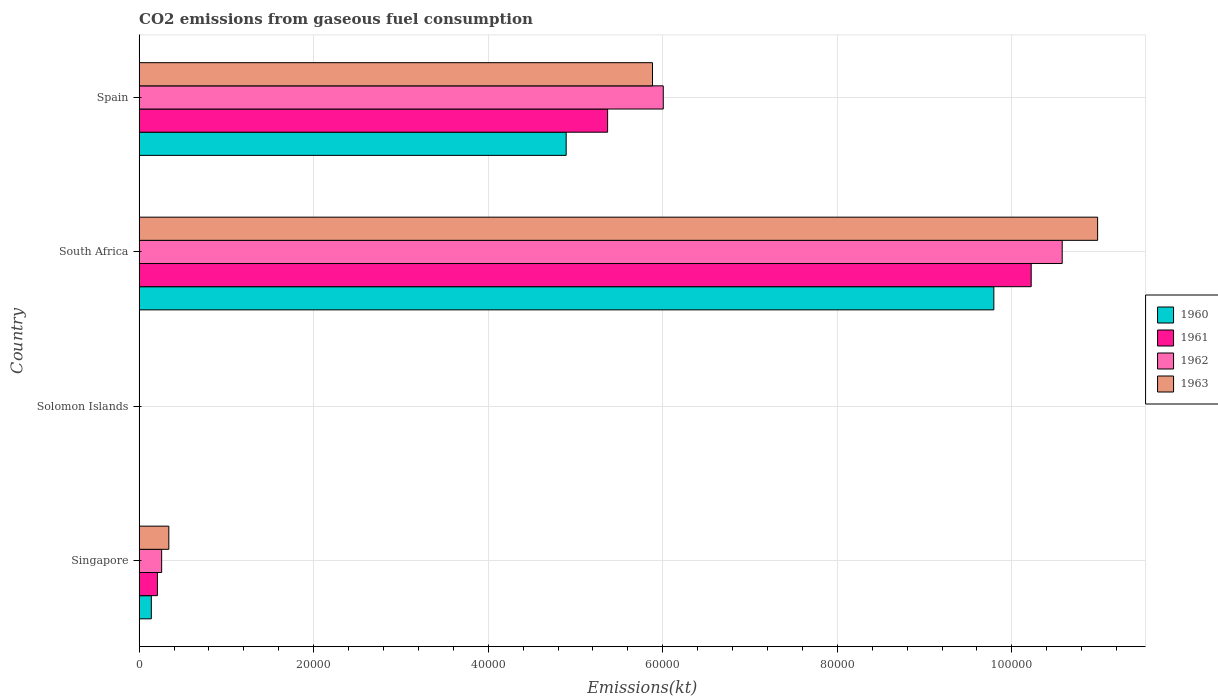How many different coloured bars are there?
Offer a terse response. 4. How many bars are there on the 2nd tick from the bottom?
Provide a succinct answer. 4. What is the label of the 2nd group of bars from the top?
Provide a short and direct response. South Africa. What is the amount of CO2 emitted in 1960 in Solomon Islands?
Ensure brevity in your answer.  11. Across all countries, what is the maximum amount of CO2 emitted in 1960?
Provide a short and direct response. 9.79e+04. Across all countries, what is the minimum amount of CO2 emitted in 1963?
Your answer should be compact. 14.67. In which country was the amount of CO2 emitted in 1961 maximum?
Your answer should be very brief. South Africa. In which country was the amount of CO2 emitted in 1963 minimum?
Offer a very short reply. Solomon Islands. What is the total amount of CO2 emitted in 1961 in the graph?
Provide a succinct answer. 1.58e+05. What is the difference between the amount of CO2 emitted in 1963 in Singapore and that in Solomon Islands?
Your answer should be compact. 3384.64. What is the difference between the amount of CO2 emitted in 1962 in Solomon Islands and the amount of CO2 emitted in 1963 in Singapore?
Make the answer very short. -3384.64. What is the average amount of CO2 emitted in 1961 per country?
Offer a terse response. 3.95e+04. What is the difference between the amount of CO2 emitted in 1961 and amount of CO2 emitted in 1960 in South Africa?
Provide a short and direct response. 4279.39. In how many countries, is the amount of CO2 emitted in 1960 greater than 64000 kt?
Provide a succinct answer. 1. What is the ratio of the amount of CO2 emitted in 1962 in Solomon Islands to that in South Africa?
Ensure brevity in your answer.  0. Is the amount of CO2 emitted in 1961 in South Africa less than that in Spain?
Your response must be concise. No. Is the difference between the amount of CO2 emitted in 1961 in Solomon Islands and South Africa greater than the difference between the amount of CO2 emitted in 1960 in Solomon Islands and South Africa?
Offer a very short reply. No. What is the difference between the highest and the second highest amount of CO2 emitted in 1963?
Your answer should be very brief. 5.10e+04. What is the difference between the highest and the lowest amount of CO2 emitted in 1960?
Give a very brief answer. 9.79e+04. Are all the bars in the graph horizontal?
Your response must be concise. Yes. How many countries are there in the graph?
Provide a short and direct response. 4. What is the difference between two consecutive major ticks on the X-axis?
Keep it short and to the point. 2.00e+04. Are the values on the major ticks of X-axis written in scientific E-notation?
Offer a very short reply. No. Does the graph contain any zero values?
Your answer should be compact. No. Does the graph contain grids?
Offer a terse response. Yes. How many legend labels are there?
Provide a short and direct response. 4. What is the title of the graph?
Give a very brief answer. CO2 emissions from gaseous fuel consumption. What is the label or title of the X-axis?
Your answer should be very brief. Emissions(kt). What is the label or title of the Y-axis?
Provide a succinct answer. Country. What is the Emissions(kt) in 1960 in Singapore?
Keep it short and to the point. 1393.46. What is the Emissions(kt) of 1961 in Singapore?
Your answer should be very brief. 2093.86. What is the Emissions(kt) of 1962 in Singapore?
Offer a terse response. 2577.9. What is the Emissions(kt) in 1963 in Singapore?
Your answer should be compact. 3399.31. What is the Emissions(kt) in 1960 in Solomon Islands?
Ensure brevity in your answer.  11. What is the Emissions(kt) in 1961 in Solomon Islands?
Make the answer very short. 14.67. What is the Emissions(kt) in 1962 in Solomon Islands?
Your answer should be compact. 14.67. What is the Emissions(kt) of 1963 in Solomon Islands?
Ensure brevity in your answer.  14.67. What is the Emissions(kt) in 1960 in South Africa?
Your response must be concise. 9.79e+04. What is the Emissions(kt) in 1961 in South Africa?
Provide a short and direct response. 1.02e+05. What is the Emissions(kt) in 1962 in South Africa?
Your answer should be very brief. 1.06e+05. What is the Emissions(kt) in 1963 in South Africa?
Offer a very short reply. 1.10e+05. What is the Emissions(kt) in 1960 in Spain?
Keep it short and to the point. 4.89e+04. What is the Emissions(kt) of 1961 in Spain?
Ensure brevity in your answer.  5.37e+04. What is the Emissions(kt) of 1962 in Spain?
Your response must be concise. 6.01e+04. What is the Emissions(kt) in 1963 in Spain?
Make the answer very short. 5.88e+04. Across all countries, what is the maximum Emissions(kt) of 1960?
Provide a short and direct response. 9.79e+04. Across all countries, what is the maximum Emissions(kt) of 1961?
Offer a very short reply. 1.02e+05. Across all countries, what is the maximum Emissions(kt) of 1962?
Keep it short and to the point. 1.06e+05. Across all countries, what is the maximum Emissions(kt) in 1963?
Your answer should be very brief. 1.10e+05. Across all countries, what is the minimum Emissions(kt) of 1960?
Offer a very short reply. 11. Across all countries, what is the minimum Emissions(kt) of 1961?
Your answer should be compact. 14.67. Across all countries, what is the minimum Emissions(kt) of 1962?
Keep it short and to the point. 14.67. Across all countries, what is the minimum Emissions(kt) in 1963?
Provide a short and direct response. 14.67. What is the total Emissions(kt) of 1960 in the graph?
Offer a terse response. 1.48e+05. What is the total Emissions(kt) of 1961 in the graph?
Ensure brevity in your answer.  1.58e+05. What is the total Emissions(kt) in 1962 in the graph?
Offer a very short reply. 1.68e+05. What is the total Emissions(kt) of 1963 in the graph?
Your response must be concise. 1.72e+05. What is the difference between the Emissions(kt) in 1960 in Singapore and that in Solomon Islands?
Offer a terse response. 1382.46. What is the difference between the Emissions(kt) of 1961 in Singapore and that in Solomon Islands?
Provide a succinct answer. 2079.19. What is the difference between the Emissions(kt) of 1962 in Singapore and that in Solomon Islands?
Offer a terse response. 2563.23. What is the difference between the Emissions(kt) of 1963 in Singapore and that in Solomon Islands?
Your answer should be very brief. 3384.64. What is the difference between the Emissions(kt) in 1960 in Singapore and that in South Africa?
Your answer should be compact. -9.65e+04. What is the difference between the Emissions(kt) in 1961 in Singapore and that in South Africa?
Make the answer very short. -1.00e+05. What is the difference between the Emissions(kt) of 1962 in Singapore and that in South Africa?
Give a very brief answer. -1.03e+05. What is the difference between the Emissions(kt) of 1963 in Singapore and that in South Africa?
Offer a terse response. -1.06e+05. What is the difference between the Emissions(kt) in 1960 in Singapore and that in Spain?
Keep it short and to the point. -4.75e+04. What is the difference between the Emissions(kt) of 1961 in Singapore and that in Spain?
Provide a short and direct response. -5.16e+04. What is the difference between the Emissions(kt) of 1962 in Singapore and that in Spain?
Ensure brevity in your answer.  -5.75e+04. What is the difference between the Emissions(kt) in 1963 in Singapore and that in Spain?
Provide a short and direct response. -5.54e+04. What is the difference between the Emissions(kt) in 1960 in Solomon Islands and that in South Africa?
Keep it short and to the point. -9.79e+04. What is the difference between the Emissions(kt) of 1961 in Solomon Islands and that in South Africa?
Give a very brief answer. -1.02e+05. What is the difference between the Emissions(kt) of 1962 in Solomon Islands and that in South Africa?
Provide a short and direct response. -1.06e+05. What is the difference between the Emissions(kt) of 1963 in Solomon Islands and that in South Africa?
Provide a short and direct response. -1.10e+05. What is the difference between the Emissions(kt) of 1960 in Solomon Islands and that in Spain?
Your response must be concise. -4.89e+04. What is the difference between the Emissions(kt) of 1961 in Solomon Islands and that in Spain?
Provide a succinct answer. -5.37e+04. What is the difference between the Emissions(kt) of 1962 in Solomon Islands and that in Spain?
Keep it short and to the point. -6.00e+04. What is the difference between the Emissions(kt) in 1963 in Solomon Islands and that in Spain?
Provide a short and direct response. -5.88e+04. What is the difference between the Emissions(kt) in 1960 in South Africa and that in Spain?
Your answer should be compact. 4.90e+04. What is the difference between the Emissions(kt) in 1961 in South Africa and that in Spain?
Make the answer very short. 4.85e+04. What is the difference between the Emissions(kt) in 1962 in South Africa and that in Spain?
Your response must be concise. 4.57e+04. What is the difference between the Emissions(kt) of 1963 in South Africa and that in Spain?
Offer a terse response. 5.10e+04. What is the difference between the Emissions(kt) in 1960 in Singapore and the Emissions(kt) in 1961 in Solomon Islands?
Offer a terse response. 1378.79. What is the difference between the Emissions(kt) of 1960 in Singapore and the Emissions(kt) of 1962 in Solomon Islands?
Keep it short and to the point. 1378.79. What is the difference between the Emissions(kt) of 1960 in Singapore and the Emissions(kt) of 1963 in Solomon Islands?
Offer a terse response. 1378.79. What is the difference between the Emissions(kt) of 1961 in Singapore and the Emissions(kt) of 1962 in Solomon Islands?
Your answer should be compact. 2079.19. What is the difference between the Emissions(kt) of 1961 in Singapore and the Emissions(kt) of 1963 in Solomon Islands?
Ensure brevity in your answer.  2079.19. What is the difference between the Emissions(kt) in 1962 in Singapore and the Emissions(kt) in 1963 in Solomon Islands?
Your response must be concise. 2563.23. What is the difference between the Emissions(kt) in 1960 in Singapore and the Emissions(kt) in 1961 in South Africa?
Provide a short and direct response. -1.01e+05. What is the difference between the Emissions(kt) of 1960 in Singapore and the Emissions(kt) of 1962 in South Africa?
Give a very brief answer. -1.04e+05. What is the difference between the Emissions(kt) in 1960 in Singapore and the Emissions(kt) in 1963 in South Africa?
Provide a succinct answer. -1.08e+05. What is the difference between the Emissions(kt) in 1961 in Singapore and the Emissions(kt) in 1962 in South Africa?
Give a very brief answer. -1.04e+05. What is the difference between the Emissions(kt) of 1961 in Singapore and the Emissions(kt) of 1963 in South Africa?
Provide a succinct answer. -1.08e+05. What is the difference between the Emissions(kt) in 1962 in Singapore and the Emissions(kt) in 1963 in South Africa?
Offer a terse response. -1.07e+05. What is the difference between the Emissions(kt) of 1960 in Singapore and the Emissions(kt) of 1961 in Spain?
Provide a succinct answer. -5.23e+04. What is the difference between the Emissions(kt) of 1960 in Singapore and the Emissions(kt) of 1962 in Spain?
Provide a short and direct response. -5.87e+04. What is the difference between the Emissions(kt) of 1960 in Singapore and the Emissions(kt) of 1963 in Spain?
Offer a terse response. -5.74e+04. What is the difference between the Emissions(kt) of 1961 in Singapore and the Emissions(kt) of 1962 in Spain?
Offer a very short reply. -5.80e+04. What is the difference between the Emissions(kt) in 1961 in Singapore and the Emissions(kt) in 1963 in Spain?
Make the answer very short. -5.67e+04. What is the difference between the Emissions(kt) in 1962 in Singapore and the Emissions(kt) in 1963 in Spain?
Your answer should be compact. -5.62e+04. What is the difference between the Emissions(kt) in 1960 in Solomon Islands and the Emissions(kt) in 1961 in South Africa?
Give a very brief answer. -1.02e+05. What is the difference between the Emissions(kt) of 1960 in Solomon Islands and the Emissions(kt) of 1962 in South Africa?
Offer a very short reply. -1.06e+05. What is the difference between the Emissions(kt) of 1960 in Solomon Islands and the Emissions(kt) of 1963 in South Africa?
Your answer should be very brief. -1.10e+05. What is the difference between the Emissions(kt) in 1961 in Solomon Islands and the Emissions(kt) in 1962 in South Africa?
Offer a very short reply. -1.06e+05. What is the difference between the Emissions(kt) of 1961 in Solomon Islands and the Emissions(kt) of 1963 in South Africa?
Your answer should be very brief. -1.10e+05. What is the difference between the Emissions(kt) of 1962 in Solomon Islands and the Emissions(kt) of 1963 in South Africa?
Your answer should be compact. -1.10e+05. What is the difference between the Emissions(kt) in 1960 in Solomon Islands and the Emissions(kt) in 1961 in Spain?
Offer a very short reply. -5.37e+04. What is the difference between the Emissions(kt) of 1960 in Solomon Islands and the Emissions(kt) of 1962 in Spain?
Offer a very short reply. -6.00e+04. What is the difference between the Emissions(kt) of 1960 in Solomon Islands and the Emissions(kt) of 1963 in Spain?
Offer a very short reply. -5.88e+04. What is the difference between the Emissions(kt) of 1961 in Solomon Islands and the Emissions(kt) of 1962 in Spain?
Offer a terse response. -6.00e+04. What is the difference between the Emissions(kt) of 1961 in Solomon Islands and the Emissions(kt) of 1963 in Spain?
Your answer should be very brief. -5.88e+04. What is the difference between the Emissions(kt) of 1962 in Solomon Islands and the Emissions(kt) of 1963 in Spain?
Your answer should be compact. -5.88e+04. What is the difference between the Emissions(kt) in 1960 in South Africa and the Emissions(kt) in 1961 in Spain?
Give a very brief answer. 4.43e+04. What is the difference between the Emissions(kt) of 1960 in South Africa and the Emissions(kt) of 1962 in Spain?
Keep it short and to the point. 3.79e+04. What is the difference between the Emissions(kt) in 1960 in South Africa and the Emissions(kt) in 1963 in Spain?
Provide a succinct answer. 3.91e+04. What is the difference between the Emissions(kt) of 1961 in South Africa and the Emissions(kt) of 1962 in Spain?
Make the answer very short. 4.22e+04. What is the difference between the Emissions(kt) in 1961 in South Africa and the Emissions(kt) in 1963 in Spain?
Offer a terse response. 4.34e+04. What is the difference between the Emissions(kt) of 1962 in South Africa and the Emissions(kt) of 1963 in Spain?
Give a very brief answer. 4.69e+04. What is the average Emissions(kt) in 1960 per country?
Make the answer very short. 3.71e+04. What is the average Emissions(kt) in 1961 per country?
Offer a very short reply. 3.95e+04. What is the average Emissions(kt) of 1962 per country?
Offer a very short reply. 4.21e+04. What is the average Emissions(kt) of 1963 per country?
Your response must be concise. 4.30e+04. What is the difference between the Emissions(kt) of 1960 and Emissions(kt) of 1961 in Singapore?
Your answer should be compact. -700.4. What is the difference between the Emissions(kt) in 1960 and Emissions(kt) in 1962 in Singapore?
Offer a very short reply. -1184.44. What is the difference between the Emissions(kt) in 1960 and Emissions(kt) in 1963 in Singapore?
Keep it short and to the point. -2005.85. What is the difference between the Emissions(kt) in 1961 and Emissions(kt) in 1962 in Singapore?
Your response must be concise. -484.04. What is the difference between the Emissions(kt) of 1961 and Emissions(kt) of 1963 in Singapore?
Provide a succinct answer. -1305.45. What is the difference between the Emissions(kt) in 1962 and Emissions(kt) in 1963 in Singapore?
Offer a terse response. -821.41. What is the difference between the Emissions(kt) in 1960 and Emissions(kt) in 1961 in Solomon Islands?
Ensure brevity in your answer.  -3.67. What is the difference between the Emissions(kt) of 1960 and Emissions(kt) of 1962 in Solomon Islands?
Keep it short and to the point. -3.67. What is the difference between the Emissions(kt) of 1960 and Emissions(kt) of 1963 in Solomon Islands?
Keep it short and to the point. -3.67. What is the difference between the Emissions(kt) in 1961 and Emissions(kt) in 1962 in Solomon Islands?
Offer a very short reply. 0. What is the difference between the Emissions(kt) of 1960 and Emissions(kt) of 1961 in South Africa?
Offer a terse response. -4279.39. What is the difference between the Emissions(kt) of 1960 and Emissions(kt) of 1962 in South Africa?
Your answer should be compact. -7832.71. What is the difference between the Emissions(kt) in 1960 and Emissions(kt) in 1963 in South Africa?
Offer a terse response. -1.19e+04. What is the difference between the Emissions(kt) of 1961 and Emissions(kt) of 1962 in South Africa?
Provide a succinct answer. -3553.32. What is the difference between the Emissions(kt) of 1961 and Emissions(kt) of 1963 in South Africa?
Make the answer very short. -7612.69. What is the difference between the Emissions(kt) in 1962 and Emissions(kt) in 1963 in South Africa?
Provide a short and direct response. -4059.37. What is the difference between the Emissions(kt) of 1960 and Emissions(kt) of 1961 in Spain?
Your answer should be very brief. -4748.77. What is the difference between the Emissions(kt) in 1960 and Emissions(kt) in 1962 in Spain?
Make the answer very short. -1.11e+04. What is the difference between the Emissions(kt) of 1960 and Emissions(kt) of 1963 in Spain?
Your answer should be very brief. -9893.57. What is the difference between the Emissions(kt) in 1961 and Emissions(kt) in 1962 in Spain?
Keep it short and to the point. -6376.91. What is the difference between the Emissions(kt) in 1961 and Emissions(kt) in 1963 in Spain?
Ensure brevity in your answer.  -5144.8. What is the difference between the Emissions(kt) of 1962 and Emissions(kt) of 1963 in Spain?
Ensure brevity in your answer.  1232.11. What is the ratio of the Emissions(kt) in 1960 in Singapore to that in Solomon Islands?
Make the answer very short. 126.67. What is the ratio of the Emissions(kt) in 1961 in Singapore to that in Solomon Islands?
Offer a very short reply. 142.75. What is the ratio of the Emissions(kt) in 1962 in Singapore to that in Solomon Islands?
Provide a short and direct response. 175.75. What is the ratio of the Emissions(kt) of 1963 in Singapore to that in Solomon Islands?
Keep it short and to the point. 231.75. What is the ratio of the Emissions(kt) in 1960 in Singapore to that in South Africa?
Make the answer very short. 0.01. What is the ratio of the Emissions(kt) of 1961 in Singapore to that in South Africa?
Give a very brief answer. 0.02. What is the ratio of the Emissions(kt) in 1962 in Singapore to that in South Africa?
Give a very brief answer. 0.02. What is the ratio of the Emissions(kt) in 1963 in Singapore to that in South Africa?
Offer a terse response. 0.03. What is the ratio of the Emissions(kt) in 1960 in Singapore to that in Spain?
Keep it short and to the point. 0.03. What is the ratio of the Emissions(kt) of 1961 in Singapore to that in Spain?
Offer a terse response. 0.04. What is the ratio of the Emissions(kt) in 1962 in Singapore to that in Spain?
Ensure brevity in your answer.  0.04. What is the ratio of the Emissions(kt) of 1963 in Singapore to that in Spain?
Keep it short and to the point. 0.06. What is the ratio of the Emissions(kt) of 1960 in Solomon Islands to that in South Africa?
Provide a short and direct response. 0. What is the ratio of the Emissions(kt) of 1961 in Solomon Islands to that in South Africa?
Provide a succinct answer. 0. What is the ratio of the Emissions(kt) in 1962 in Solomon Islands to that in South Africa?
Give a very brief answer. 0. What is the ratio of the Emissions(kt) of 1963 in Solomon Islands to that in South Africa?
Make the answer very short. 0. What is the ratio of the Emissions(kt) of 1961 in Solomon Islands to that in Spain?
Provide a short and direct response. 0. What is the ratio of the Emissions(kt) of 1963 in Solomon Islands to that in Spain?
Your answer should be compact. 0. What is the ratio of the Emissions(kt) in 1960 in South Africa to that in Spain?
Make the answer very short. 2. What is the ratio of the Emissions(kt) in 1961 in South Africa to that in Spain?
Ensure brevity in your answer.  1.9. What is the ratio of the Emissions(kt) of 1962 in South Africa to that in Spain?
Your response must be concise. 1.76. What is the ratio of the Emissions(kt) of 1963 in South Africa to that in Spain?
Your answer should be very brief. 1.87. What is the difference between the highest and the second highest Emissions(kt) of 1960?
Offer a terse response. 4.90e+04. What is the difference between the highest and the second highest Emissions(kt) in 1961?
Give a very brief answer. 4.85e+04. What is the difference between the highest and the second highest Emissions(kt) in 1962?
Your answer should be very brief. 4.57e+04. What is the difference between the highest and the second highest Emissions(kt) in 1963?
Your answer should be compact. 5.10e+04. What is the difference between the highest and the lowest Emissions(kt) of 1960?
Make the answer very short. 9.79e+04. What is the difference between the highest and the lowest Emissions(kt) of 1961?
Provide a short and direct response. 1.02e+05. What is the difference between the highest and the lowest Emissions(kt) in 1962?
Provide a short and direct response. 1.06e+05. What is the difference between the highest and the lowest Emissions(kt) of 1963?
Your answer should be compact. 1.10e+05. 